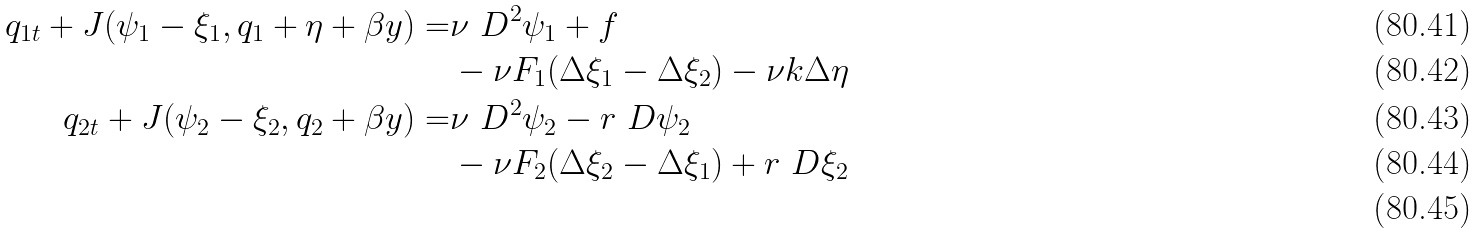<formula> <loc_0><loc_0><loc_500><loc_500>q _ { 1 t } + J ( \psi _ { 1 } - \xi _ { 1 } , q _ { 1 } + \eta + \beta y ) = & \nu \ D ^ { 2 } \psi _ { 1 } + f \\ & - \nu F _ { 1 } ( \Delta \xi _ { 1 } - \Delta \xi _ { 2 } ) - \nu k \Delta \eta \\ q _ { 2 t } + J ( \psi _ { 2 } - \xi _ { 2 } , q _ { 2 } + \beta y ) = & \nu \ D ^ { 2 } \psi _ { 2 } - r \ D \psi _ { 2 } \\ & - \nu F _ { 2 } ( \Delta \xi _ { 2 } - \Delta \xi _ { 1 } ) + r \ D \xi _ { 2 } \\</formula> 